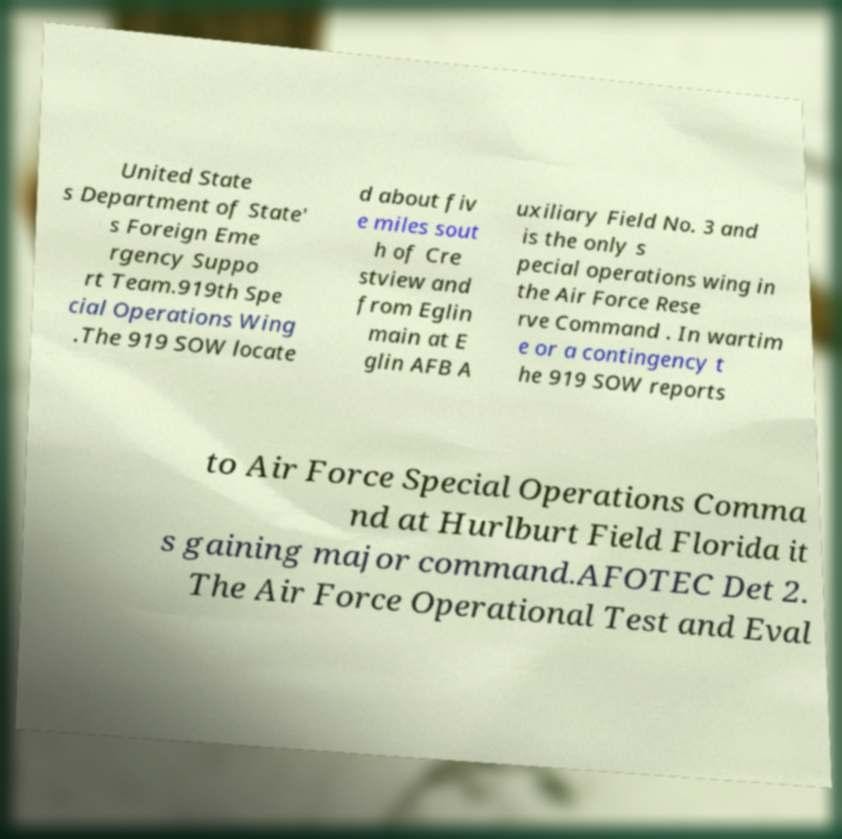Please read and relay the text visible in this image. What does it say? United State s Department of State' s Foreign Eme rgency Suppo rt Team.919th Spe cial Operations Wing .The 919 SOW locate d about fiv e miles sout h of Cre stview and from Eglin main at E glin AFB A uxiliary Field No. 3 and is the only s pecial operations wing in the Air Force Rese rve Command . In wartim e or a contingency t he 919 SOW reports to Air Force Special Operations Comma nd at Hurlburt Field Florida it s gaining major command.AFOTEC Det 2. The Air Force Operational Test and Eval 